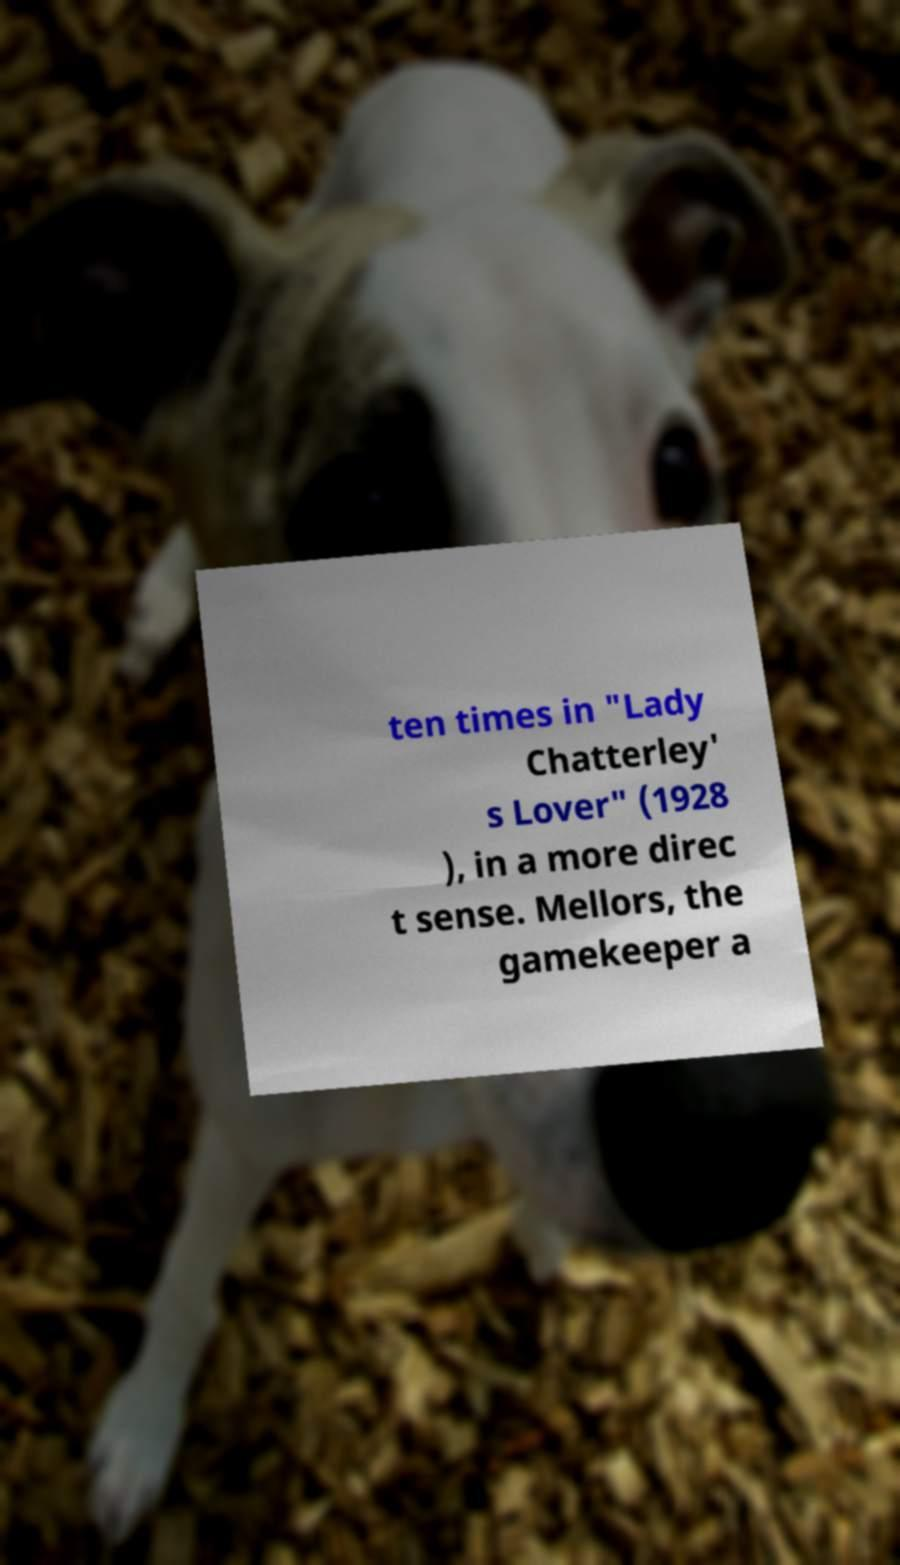What messages or text are displayed in this image? I need them in a readable, typed format. ten times in "Lady Chatterley' s Lover" (1928 ), in a more direc t sense. Mellors, the gamekeeper a 